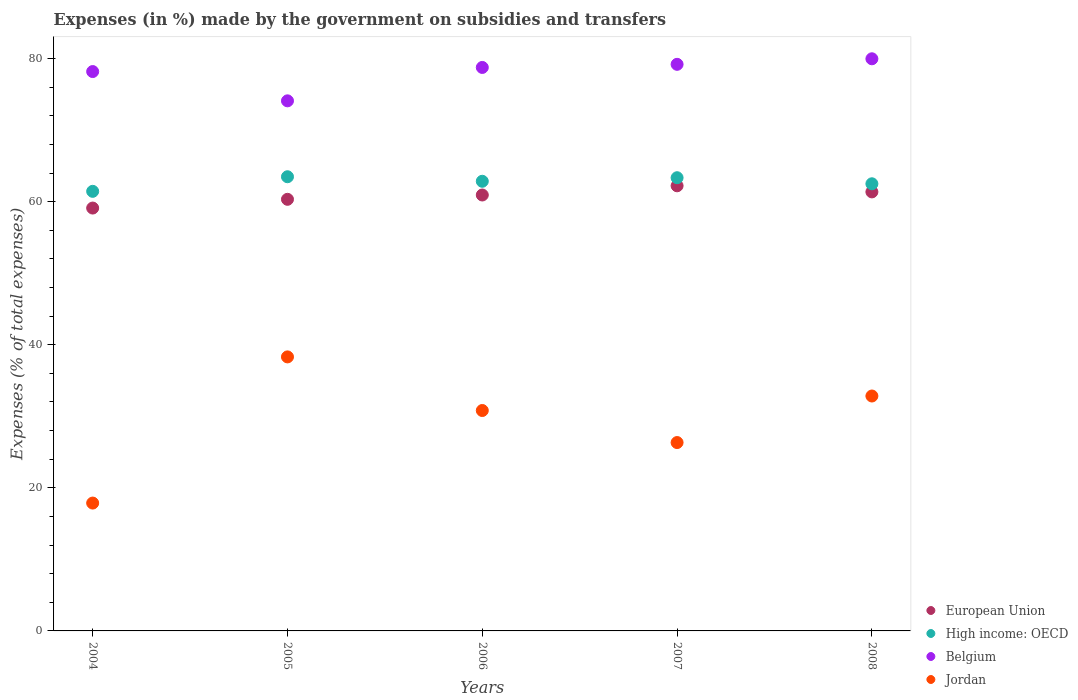Is the number of dotlines equal to the number of legend labels?
Ensure brevity in your answer.  Yes. What is the percentage of expenses made by the government on subsidies and transfers in Jordan in 2005?
Offer a very short reply. 38.3. Across all years, what is the maximum percentage of expenses made by the government on subsidies and transfers in High income: OECD?
Offer a very short reply. 63.48. Across all years, what is the minimum percentage of expenses made by the government on subsidies and transfers in European Union?
Make the answer very short. 59.11. In which year was the percentage of expenses made by the government on subsidies and transfers in Jordan maximum?
Give a very brief answer. 2005. In which year was the percentage of expenses made by the government on subsidies and transfers in Jordan minimum?
Offer a terse response. 2004. What is the total percentage of expenses made by the government on subsidies and transfers in Jordan in the graph?
Provide a short and direct response. 146.15. What is the difference between the percentage of expenses made by the government on subsidies and transfers in High income: OECD in 2004 and that in 2005?
Your answer should be very brief. -2.04. What is the difference between the percentage of expenses made by the government on subsidies and transfers in European Union in 2004 and the percentage of expenses made by the government on subsidies and transfers in Jordan in 2005?
Provide a succinct answer. 20.8. What is the average percentage of expenses made by the government on subsidies and transfers in Jordan per year?
Make the answer very short. 29.23. In the year 2006, what is the difference between the percentage of expenses made by the government on subsidies and transfers in Belgium and percentage of expenses made by the government on subsidies and transfers in European Union?
Your response must be concise. 17.83. What is the ratio of the percentage of expenses made by the government on subsidies and transfers in European Union in 2007 to that in 2008?
Offer a very short reply. 1.01. Is the difference between the percentage of expenses made by the government on subsidies and transfers in Belgium in 2004 and 2007 greater than the difference between the percentage of expenses made by the government on subsidies and transfers in European Union in 2004 and 2007?
Your answer should be very brief. Yes. What is the difference between the highest and the second highest percentage of expenses made by the government on subsidies and transfers in Jordan?
Your answer should be very brief. 5.47. What is the difference between the highest and the lowest percentage of expenses made by the government on subsidies and transfers in Belgium?
Ensure brevity in your answer.  5.88. In how many years, is the percentage of expenses made by the government on subsidies and transfers in European Union greater than the average percentage of expenses made by the government on subsidies and transfers in European Union taken over all years?
Your answer should be compact. 3. Is the sum of the percentage of expenses made by the government on subsidies and transfers in European Union in 2007 and 2008 greater than the maximum percentage of expenses made by the government on subsidies and transfers in High income: OECD across all years?
Make the answer very short. Yes. Is it the case that in every year, the sum of the percentage of expenses made by the government on subsidies and transfers in Belgium and percentage of expenses made by the government on subsidies and transfers in European Union  is greater than the percentage of expenses made by the government on subsidies and transfers in High income: OECD?
Give a very brief answer. Yes. Is the percentage of expenses made by the government on subsidies and transfers in European Union strictly greater than the percentage of expenses made by the government on subsidies and transfers in Jordan over the years?
Your answer should be very brief. Yes. What is the difference between two consecutive major ticks on the Y-axis?
Provide a short and direct response. 20. Are the values on the major ticks of Y-axis written in scientific E-notation?
Your answer should be compact. No. How are the legend labels stacked?
Offer a very short reply. Vertical. What is the title of the graph?
Give a very brief answer. Expenses (in %) made by the government on subsidies and transfers. Does "Japan" appear as one of the legend labels in the graph?
Ensure brevity in your answer.  No. What is the label or title of the Y-axis?
Offer a very short reply. Expenses (% of total expenses). What is the Expenses (% of total expenses) in European Union in 2004?
Make the answer very short. 59.11. What is the Expenses (% of total expenses) of High income: OECD in 2004?
Your response must be concise. 61.44. What is the Expenses (% of total expenses) in Belgium in 2004?
Keep it short and to the point. 78.19. What is the Expenses (% of total expenses) in Jordan in 2004?
Provide a succinct answer. 17.87. What is the Expenses (% of total expenses) in European Union in 2005?
Your response must be concise. 60.33. What is the Expenses (% of total expenses) of High income: OECD in 2005?
Give a very brief answer. 63.48. What is the Expenses (% of total expenses) of Belgium in 2005?
Provide a short and direct response. 74.09. What is the Expenses (% of total expenses) in Jordan in 2005?
Ensure brevity in your answer.  38.3. What is the Expenses (% of total expenses) in European Union in 2006?
Make the answer very short. 60.93. What is the Expenses (% of total expenses) in High income: OECD in 2006?
Provide a short and direct response. 62.85. What is the Expenses (% of total expenses) of Belgium in 2006?
Your answer should be very brief. 78.76. What is the Expenses (% of total expenses) of Jordan in 2006?
Your answer should be compact. 30.81. What is the Expenses (% of total expenses) in European Union in 2007?
Make the answer very short. 62.22. What is the Expenses (% of total expenses) of High income: OECD in 2007?
Your answer should be compact. 63.35. What is the Expenses (% of total expenses) of Belgium in 2007?
Make the answer very short. 79.2. What is the Expenses (% of total expenses) of Jordan in 2007?
Ensure brevity in your answer.  26.33. What is the Expenses (% of total expenses) of European Union in 2008?
Provide a succinct answer. 61.36. What is the Expenses (% of total expenses) of High income: OECD in 2008?
Make the answer very short. 62.5. What is the Expenses (% of total expenses) of Belgium in 2008?
Offer a terse response. 79.97. What is the Expenses (% of total expenses) of Jordan in 2008?
Make the answer very short. 32.84. Across all years, what is the maximum Expenses (% of total expenses) of European Union?
Give a very brief answer. 62.22. Across all years, what is the maximum Expenses (% of total expenses) in High income: OECD?
Make the answer very short. 63.48. Across all years, what is the maximum Expenses (% of total expenses) in Belgium?
Your answer should be very brief. 79.97. Across all years, what is the maximum Expenses (% of total expenses) in Jordan?
Your answer should be compact. 38.3. Across all years, what is the minimum Expenses (% of total expenses) of European Union?
Your answer should be compact. 59.11. Across all years, what is the minimum Expenses (% of total expenses) of High income: OECD?
Offer a very short reply. 61.44. Across all years, what is the minimum Expenses (% of total expenses) in Belgium?
Keep it short and to the point. 74.09. Across all years, what is the minimum Expenses (% of total expenses) of Jordan?
Give a very brief answer. 17.87. What is the total Expenses (% of total expenses) in European Union in the graph?
Give a very brief answer. 303.95. What is the total Expenses (% of total expenses) in High income: OECD in the graph?
Your answer should be very brief. 313.62. What is the total Expenses (% of total expenses) of Belgium in the graph?
Provide a short and direct response. 390.2. What is the total Expenses (% of total expenses) of Jordan in the graph?
Provide a succinct answer. 146.15. What is the difference between the Expenses (% of total expenses) in European Union in 2004 and that in 2005?
Your response must be concise. -1.22. What is the difference between the Expenses (% of total expenses) of High income: OECD in 2004 and that in 2005?
Make the answer very short. -2.04. What is the difference between the Expenses (% of total expenses) in Belgium in 2004 and that in 2005?
Offer a very short reply. 4.09. What is the difference between the Expenses (% of total expenses) in Jordan in 2004 and that in 2005?
Keep it short and to the point. -20.43. What is the difference between the Expenses (% of total expenses) in European Union in 2004 and that in 2006?
Ensure brevity in your answer.  -1.83. What is the difference between the Expenses (% of total expenses) in High income: OECD in 2004 and that in 2006?
Your answer should be compact. -1.41. What is the difference between the Expenses (% of total expenses) in Belgium in 2004 and that in 2006?
Provide a short and direct response. -0.57. What is the difference between the Expenses (% of total expenses) in Jordan in 2004 and that in 2006?
Offer a terse response. -12.94. What is the difference between the Expenses (% of total expenses) of European Union in 2004 and that in 2007?
Your response must be concise. -3.11. What is the difference between the Expenses (% of total expenses) in High income: OECD in 2004 and that in 2007?
Keep it short and to the point. -1.9. What is the difference between the Expenses (% of total expenses) of Belgium in 2004 and that in 2007?
Provide a succinct answer. -1.01. What is the difference between the Expenses (% of total expenses) in Jordan in 2004 and that in 2007?
Your answer should be compact. -8.46. What is the difference between the Expenses (% of total expenses) of European Union in 2004 and that in 2008?
Provide a succinct answer. -2.26. What is the difference between the Expenses (% of total expenses) in High income: OECD in 2004 and that in 2008?
Offer a terse response. -1.06. What is the difference between the Expenses (% of total expenses) of Belgium in 2004 and that in 2008?
Give a very brief answer. -1.79. What is the difference between the Expenses (% of total expenses) in Jordan in 2004 and that in 2008?
Make the answer very short. -14.96. What is the difference between the Expenses (% of total expenses) in European Union in 2005 and that in 2006?
Your response must be concise. -0.6. What is the difference between the Expenses (% of total expenses) of High income: OECD in 2005 and that in 2006?
Keep it short and to the point. 0.63. What is the difference between the Expenses (% of total expenses) in Belgium in 2005 and that in 2006?
Your response must be concise. -4.67. What is the difference between the Expenses (% of total expenses) in Jordan in 2005 and that in 2006?
Offer a very short reply. 7.49. What is the difference between the Expenses (% of total expenses) in European Union in 2005 and that in 2007?
Make the answer very short. -1.89. What is the difference between the Expenses (% of total expenses) of High income: OECD in 2005 and that in 2007?
Keep it short and to the point. 0.14. What is the difference between the Expenses (% of total expenses) in Belgium in 2005 and that in 2007?
Offer a very short reply. -5.1. What is the difference between the Expenses (% of total expenses) of Jordan in 2005 and that in 2007?
Provide a succinct answer. 11.97. What is the difference between the Expenses (% of total expenses) of European Union in 2005 and that in 2008?
Your answer should be compact. -1.04. What is the difference between the Expenses (% of total expenses) in High income: OECD in 2005 and that in 2008?
Offer a very short reply. 0.98. What is the difference between the Expenses (% of total expenses) of Belgium in 2005 and that in 2008?
Give a very brief answer. -5.88. What is the difference between the Expenses (% of total expenses) in Jordan in 2005 and that in 2008?
Provide a succinct answer. 5.47. What is the difference between the Expenses (% of total expenses) of European Union in 2006 and that in 2007?
Ensure brevity in your answer.  -1.29. What is the difference between the Expenses (% of total expenses) of High income: OECD in 2006 and that in 2007?
Make the answer very short. -0.5. What is the difference between the Expenses (% of total expenses) of Belgium in 2006 and that in 2007?
Give a very brief answer. -0.44. What is the difference between the Expenses (% of total expenses) in Jordan in 2006 and that in 2007?
Offer a very short reply. 4.48. What is the difference between the Expenses (% of total expenses) of European Union in 2006 and that in 2008?
Make the answer very short. -0.43. What is the difference between the Expenses (% of total expenses) of High income: OECD in 2006 and that in 2008?
Keep it short and to the point. 0.35. What is the difference between the Expenses (% of total expenses) in Belgium in 2006 and that in 2008?
Ensure brevity in your answer.  -1.21. What is the difference between the Expenses (% of total expenses) in Jordan in 2006 and that in 2008?
Your answer should be very brief. -2.03. What is the difference between the Expenses (% of total expenses) of European Union in 2007 and that in 2008?
Give a very brief answer. 0.85. What is the difference between the Expenses (% of total expenses) in High income: OECD in 2007 and that in 2008?
Your answer should be very brief. 0.85. What is the difference between the Expenses (% of total expenses) of Belgium in 2007 and that in 2008?
Make the answer very short. -0.77. What is the difference between the Expenses (% of total expenses) in Jordan in 2007 and that in 2008?
Keep it short and to the point. -6.51. What is the difference between the Expenses (% of total expenses) in European Union in 2004 and the Expenses (% of total expenses) in High income: OECD in 2005?
Make the answer very short. -4.38. What is the difference between the Expenses (% of total expenses) in European Union in 2004 and the Expenses (% of total expenses) in Belgium in 2005?
Your response must be concise. -14.99. What is the difference between the Expenses (% of total expenses) in European Union in 2004 and the Expenses (% of total expenses) in Jordan in 2005?
Provide a short and direct response. 20.8. What is the difference between the Expenses (% of total expenses) in High income: OECD in 2004 and the Expenses (% of total expenses) in Belgium in 2005?
Your response must be concise. -12.65. What is the difference between the Expenses (% of total expenses) of High income: OECD in 2004 and the Expenses (% of total expenses) of Jordan in 2005?
Keep it short and to the point. 23.14. What is the difference between the Expenses (% of total expenses) of Belgium in 2004 and the Expenses (% of total expenses) of Jordan in 2005?
Your answer should be compact. 39.88. What is the difference between the Expenses (% of total expenses) of European Union in 2004 and the Expenses (% of total expenses) of High income: OECD in 2006?
Make the answer very short. -3.74. What is the difference between the Expenses (% of total expenses) in European Union in 2004 and the Expenses (% of total expenses) in Belgium in 2006?
Give a very brief answer. -19.65. What is the difference between the Expenses (% of total expenses) of European Union in 2004 and the Expenses (% of total expenses) of Jordan in 2006?
Your answer should be compact. 28.3. What is the difference between the Expenses (% of total expenses) of High income: OECD in 2004 and the Expenses (% of total expenses) of Belgium in 2006?
Provide a short and direct response. -17.32. What is the difference between the Expenses (% of total expenses) of High income: OECD in 2004 and the Expenses (% of total expenses) of Jordan in 2006?
Offer a terse response. 30.64. What is the difference between the Expenses (% of total expenses) in Belgium in 2004 and the Expenses (% of total expenses) in Jordan in 2006?
Your response must be concise. 47.38. What is the difference between the Expenses (% of total expenses) of European Union in 2004 and the Expenses (% of total expenses) of High income: OECD in 2007?
Give a very brief answer. -4.24. What is the difference between the Expenses (% of total expenses) of European Union in 2004 and the Expenses (% of total expenses) of Belgium in 2007?
Your response must be concise. -20.09. What is the difference between the Expenses (% of total expenses) of European Union in 2004 and the Expenses (% of total expenses) of Jordan in 2007?
Keep it short and to the point. 32.78. What is the difference between the Expenses (% of total expenses) of High income: OECD in 2004 and the Expenses (% of total expenses) of Belgium in 2007?
Your response must be concise. -17.75. What is the difference between the Expenses (% of total expenses) of High income: OECD in 2004 and the Expenses (% of total expenses) of Jordan in 2007?
Offer a terse response. 35.11. What is the difference between the Expenses (% of total expenses) in Belgium in 2004 and the Expenses (% of total expenses) in Jordan in 2007?
Your answer should be compact. 51.86. What is the difference between the Expenses (% of total expenses) of European Union in 2004 and the Expenses (% of total expenses) of High income: OECD in 2008?
Your response must be concise. -3.39. What is the difference between the Expenses (% of total expenses) of European Union in 2004 and the Expenses (% of total expenses) of Belgium in 2008?
Make the answer very short. -20.86. What is the difference between the Expenses (% of total expenses) of European Union in 2004 and the Expenses (% of total expenses) of Jordan in 2008?
Your answer should be very brief. 26.27. What is the difference between the Expenses (% of total expenses) of High income: OECD in 2004 and the Expenses (% of total expenses) of Belgium in 2008?
Offer a very short reply. -18.53. What is the difference between the Expenses (% of total expenses) of High income: OECD in 2004 and the Expenses (% of total expenses) of Jordan in 2008?
Your answer should be very brief. 28.61. What is the difference between the Expenses (% of total expenses) in Belgium in 2004 and the Expenses (% of total expenses) in Jordan in 2008?
Offer a terse response. 45.35. What is the difference between the Expenses (% of total expenses) of European Union in 2005 and the Expenses (% of total expenses) of High income: OECD in 2006?
Your answer should be very brief. -2.52. What is the difference between the Expenses (% of total expenses) in European Union in 2005 and the Expenses (% of total expenses) in Belgium in 2006?
Offer a very short reply. -18.43. What is the difference between the Expenses (% of total expenses) in European Union in 2005 and the Expenses (% of total expenses) in Jordan in 2006?
Your response must be concise. 29.52. What is the difference between the Expenses (% of total expenses) of High income: OECD in 2005 and the Expenses (% of total expenses) of Belgium in 2006?
Provide a short and direct response. -15.28. What is the difference between the Expenses (% of total expenses) of High income: OECD in 2005 and the Expenses (% of total expenses) of Jordan in 2006?
Your answer should be very brief. 32.67. What is the difference between the Expenses (% of total expenses) in Belgium in 2005 and the Expenses (% of total expenses) in Jordan in 2006?
Your response must be concise. 43.28. What is the difference between the Expenses (% of total expenses) in European Union in 2005 and the Expenses (% of total expenses) in High income: OECD in 2007?
Your response must be concise. -3.02. What is the difference between the Expenses (% of total expenses) of European Union in 2005 and the Expenses (% of total expenses) of Belgium in 2007?
Offer a very short reply. -18.87. What is the difference between the Expenses (% of total expenses) of European Union in 2005 and the Expenses (% of total expenses) of Jordan in 2007?
Your answer should be very brief. 34. What is the difference between the Expenses (% of total expenses) of High income: OECD in 2005 and the Expenses (% of total expenses) of Belgium in 2007?
Make the answer very short. -15.71. What is the difference between the Expenses (% of total expenses) in High income: OECD in 2005 and the Expenses (% of total expenses) in Jordan in 2007?
Offer a terse response. 37.15. What is the difference between the Expenses (% of total expenses) of Belgium in 2005 and the Expenses (% of total expenses) of Jordan in 2007?
Your answer should be very brief. 47.76. What is the difference between the Expenses (% of total expenses) of European Union in 2005 and the Expenses (% of total expenses) of High income: OECD in 2008?
Provide a succinct answer. -2.17. What is the difference between the Expenses (% of total expenses) of European Union in 2005 and the Expenses (% of total expenses) of Belgium in 2008?
Ensure brevity in your answer.  -19.64. What is the difference between the Expenses (% of total expenses) in European Union in 2005 and the Expenses (% of total expenses) in Jordan in 2008?
Give a very brief answer. 27.49. What is the difference between the Expenses (% of total expenses) in High income: OECD in 2005 and the Expenses (% of total expenses) in Belgium in 2008?
Offer a very short reply. -16.49. What is the difference between the Expenses (% of total expenses) in High income: OECD in 2005 and the Expenses (% of total expenses) in Jordan in 2008?
Your response must be concise. 30.65. What is the difference between the Expenses (% of total expenses) in Belgium in 2005 and the Expenses (% of total expenses) in Jordan in 2008?
Provide a succinct answer. 41.26. What is the difference between the Expenses (% of total expenses) of European Union in 2006 and the Expenses (% of total expenses) of High income: OECD in 2007?
Your answer should be very brief. -2.41. What is the difference between the Expenses (% of total expenses) in European Union in 2006 and the Expenses (% of total expenses) in Belgium in 2007?
Make the answer very short. -18.26. What is the difference between the Expenses (% of total expenses) of European Union in 2006 and the Expenses (% of total expenses) of Jordan in 2007?
Your response must be concise. 34.6. What is the difference between the Expenses (% of total expenses) in High income: OECD in 2006 and the Expenses (% of total expenses) in Belgium in 2007?
Keep it short and to the point. -16.35. What is the difference between the Expenses (% of total expenses) in High income: OECD in 2006 and the Expenses (% of total expenses) in Jordan in 2007?
Ensure brevity in your answer.  36.52. What is the difference between the Expenses (% of total expenses) of Belgium in 2006 and the Expenses (% of total expenses) of Jordan in 2007?
Provide a succinct answer. 52.43. What is the difference between the Expenses (% of total expenses) in European Union in 2006 and the Expenses (% of total expenses) in High income: OECD in 2008?
Offer a very short reply. -1.57. What is the difference between the Expenses (% of total expenses) of European Union in 2006 and the Expenses (% of total expenses) of Belgium in 2008?
Ensure brevity in your answer.  -19.04. What is the difference between the Expenses (% of total expenses) in European Union in 2006 and the Expenses (% of total expenses) in Jordan in 2008?
Give a very brief answer. 28.1. What is the difference between the Expenses (% of total expenses) in High income: OECD in 2006 and the Expenses (% of total expenses) in Belgium in 2008?
Make the answer very short. -17.12. What is the difference between the Expenses (% of total expenses) of High income: OECD in 2006 and the Expenses (% of total expenses) of Jordan in 2008?
Your answer should be compact. 30.01. What is the difference between the Expenses (% of total expenses) in Belgium in 2006 and the Expenses (% of total expenses) in Jordan in 2008?
Your response must be concise. 45.92. What is the difference between the Expenses (% of total expenses) in European Union in 2007 and the Expenses (% of total expenses) in High income: OECD in 2008?
Provide a succinct answer. -0.28. What is the difference between the Expenses (% of total expenses) in European Union in 2007 and the Expenses (% of total expenses) in Belgium in 2008?
Give a very brief answer. -17.75. What is the difference between the Expenses (% of total expenses) of European Union in 2007 and the Expenses (% of total expenses) of Jordan in 2008?
Your answer should be compact. 29.38. What is the difference between the Expenses (% of total expenses) in High income: OECD in 2007 and the Expenses (% of total expenses) in Belgium in 2008?
Offer a very short reply. -16.62. What is the difference between the Expenses (% of total expenses) of High income: OECD in 2007 and the Expenses (% of total expenses) of Jordan in 2008?
Give a very brief answer. 30.51. What is the difference between the Expenses (% of total expenses) of Belgium in 2007 and the Expenses (% of total expenses) of Jordan in 2008?
Make the answer very short. 46.36. What is the average Expenses (% of total expenses) of European Union per year?
Offer a very short reply. 60.79. What is the average Expenses (% of total expenses) in High income: OECD per year?
Make the answer very short. 62.72. What is the average Expenses (% of total expenses) of Belgium per year?
Your response must be concise. 78.04. What is the average Expenses (% of total expenses) in Jordan per year?
Provide a short and direct response. 29.23. In the year 2004, what is the difference between the Expenses (% of total expenses) of European Union and Expenses (% of total expenses) of High income: OECD?
Offer a very short reply. -2.34. In the year 2004, what is the difference between the Expenses (% of total expenses) of European Union and Expenses (% of total expenses) of Belgium?
Offer a terse response. -19.08. In the year 2004, what is the difference between the Expenses (% of total expenses) in European Union and Expenses (% of total expenses) in Jordan?
Your answer should be very brief. 41.23. In the year 2004, what is the difference between the Expenses (% of total expenses) in High income: OECD and Expenses (% of total expenses) in Belgium?
Ensure brevity in your answer.  -16.74. In the year 2004, what is the difference between the Expenses (% of total expenses) in High income: OECD and Expenses (% of total expenses) in Jordan?
Your response must be concise. 43.57. In the year 2004, what is the difference between the Expenses (% of total expenses) in Belgium and Expenses (% of total expenses) in Jordan?
Provide a short and direct response. 60.31. In the year 2005, what is the difference between the Expenses (% of total expenses) in European Union and Expenses (% of total expenses) in High income: OECD?
Offer a very short reply. -3.15. In the year 2005, what is the difference between the Expenses (% of total expenses) in European Union and Expenses (% of total expenses) in Belgium?
Offer a terse response. -13.76. In the year 2005, what is the difference between the Expenses (% of total expenses) of European Union and Expenses (% of total expenses) of Jordan?
Offer a very short reply. 22.03. In the year 2005, what is the difference between the Expenses (% of total expenses) in High income: OECD and Expenses (% of total expenses) in Belgium?
Provide a short and direct response. -10.61. In the year 2005, what is the difference between the Expenses (% of total expenses) in High income: OECD and Expenses (% of total expenses) in Jordan?
Keep it short and to the point. 25.18. In the year 2005, what is the difference between the Expenses (% of total expenses) of Belgium and Expenses (% of total expenses) of Jordan?
Give a very brief answer. 35.79. In the year 2006, what is the difference between the Expenses (% of total expenses) of European Union and Expenses (% of total expenses) of High income: OECD?
Offer a very short reply. -1.92. In the year 2006, what is the difference between the Expenses (% of total expenses) in European Union and Expenses (% of total expenses) in Belgium?
Offer a very short reply. -17.83. In the year 2006, what is the difference between the Expenses (% of total expenses) in European Union and Expenses (% of total expenses) in Jordan?
Offer a terse response. 30.12. In the year 2006, what is the difference between the Expenses (% of total expenses) of High income: OECD and Expenses (% of total expenses) of Belgium?
Give a very brief answer. -15.91. In the year 2006, what is the difference between the Expenses (% of total expenses) in High income: OECD and Expenses (% of total expenses) in Jordan?
Offer a very short reply. 32.04. In the year 2006, what is the difference between the Expenses (% of total expenses) in Belgium and Expenses (% of total expenses) in Jordan?
Make the answer very short. 47.95. In the year 2007, what is the difference between the Expenses (% of total expenses) of European Union and Expenses (% of total expenses) of High income: OECD?
Provide a succinct answer. -1.13. In the year 2007, what is the difference between the Expenses (% of total expenses) of European Union and Expenses (% of total expenses) of Belgium?
Make the answer very short. -16.98. In the year 2007, what is the difference between the Expenses (% of total expenses) in European Union and Expenses (% of total expenses) in Jordan?
Offer a very short reply. 35.89. In the year 2007, what is the difference between the Expenses (% of total expenses) in High income: OECD and Expenses (% of total expenses) in Belgium?
Your answer should be very brief. -15.85. In the year 2007, what is the difference between the Expenses (% of total expenses) of High income: OECD and Expenses (% of total expenses) of Jordan?
Your answer should be compact. 37.02. In the year 2007, what is the difference between the Expenses (% of total expenses) in Belgium and Expenses (% of total expenses) in Jordan?
Offer a very short reply. 52.87. In the year 2008, what is the difference between the Expenses (% of total expenses) in European Union and Expenses (% of total expenses) in High income: OECD?
Give a very brief answer. -1.14. In the year 2008, what is the difference between the Expenses (% of total expenses) of European Union and Expenses (% of total expenses) of Belgium?
Your response must be concise. -18.61. In the year 2008, what is the difference between the Expenses (% of total expenses) in European Union and Expenses (% of total expenses) in Jordan?
Make the answer very short. 28.53. In the year 2008, what is the difference between the Expenses (% of total expenses) in High income: OECD and Expenses (% of total expenses) in Belgium?
Make the answer very short. -17.47. In the year 2008, what is the difference between the Expenses (% of total expenses) of High income: OECD and Expenses (% of total expenses) of Jordan?
Make the answer very short. 29.66. In the year 2008, what is the difference between the Expenses (% of total expenses) of Belgium and Expenses (% of total expenses) of Jordan?
Make the answer very short. 47.14. What is the ratio of the Expenses (% of total expenses) in European Union in 2004 to that in 2005?
Your response must be concise. 0.98. What is the ratio of the Expenses (% of total expenses) in High income: OECD in 2004 to that in 2005?
Offer a very short reply. 0.97. What is the ratio of the Expenses (% of total expenses) in Belgium in 2004 to that in 2005?
Give a very brief answer. 1.06. What is the ratio of the Expenses (% of total expenses) of Jordan in 2004 to that in 2005?
Offer a very short reply. 0.47. What is the ratio of the Expenses (% of total expenses) of European Union in 2004 to that in 2006?
Give a very brief answer. 0.97. What is the ratio of the Expenses (% of total expenses) in High income: OECD in 2004 to that in 2006?
Make the answer very short. 0.98. What is the ratio of the Expenses (% of total expenses) of Jordan in 2004 to that in 2006?
Keep it short and to the point. 0.58. What is the ratio of the Expenses (% of total expenses) of European Union in 2004 to that in 2007?
Your response must be concise. 0.95. What is the ratio of the Expenses (% of total expenses) of High income: OECD in 2004 to that in 2007?
Make the answer very short. 0.97. What is the ratio of the Expenses (% of total expenses) in Belgium in 2004 to that in 2007?
Provide a succinct answer. 0.99. What is the ratio of the Expenses (% of total expenses) of Jordan in 2004 to that in 2007?
Give a very brief answer. 0.68. What is the ratio of the Expenses (% of total expenses) of European Union in 2004 to that in 2008?
Offer a terse response. 0.96. What is the ratio of the Expenses (% of total expenses) of High income: OECD in 2004 to that in 2008?
Provide a succinct answer. 0.98. What is the ratio of the Expenses (% of total expenses) in Belgium in 2004 to that in 2008?
Provide a succinct answer. 0.98. What is the ratio of the Expenses (% of total expenses) in Jordan in 2004 to that in 2008?
Provide a short and direct response. 0.54. What is the ratio of the Expenses (% of total expenses) in European Union in 2005 to that in 2006?
Your response must be concise. 0.99. What is the ratio of the Expenses (% of total expenses) of Belgium in 2005 to that in 2006?
Offer a terse response. 0.94. What is the ratio of the Expenses (% of total expenses) in Jordan in 2005 to that in 2006?
Offer a very short reply. 1.24. What is the ratio of the Expenses (% of total expenses) in European Union in 2005 to that in 2007?
Ensure brevity in your answer.  0.97. What is the ratio of the Expenses (% of total expenses) in Belgium in 2005 to that in 2007?
Ensure brevity in your answer.  0.94. What is the ratio of the Expenses (% of total expenses) of Jordan in 2005 to that in 2007?
Your answer should be very brief. 1.45. What is the ratio of the Expenses (% of total expenses) in European Union in 2005 to that in 2008?
Give a very brief answer. 0.98. What is the ratio of the Expenses (% of total expenses) in High income: OECD in 2005 to that in 2008?
Offer a terse response. 1.02. What is the ratio of the Expenses (% of total expenses) of Belgium in 2005 to that in 2008?
Your answer should be compact. 0.93. What is the ratio of the Expenses (% of total expenses) of Jordan in 2005 to that in 2008?
Offer a very short reply. 1.17. What is the ratio of the Expenses (% of total expenses) in European Union in 2006 to that in 2007?
Offer a terse response. 0.98. What is the ratio of the Expenses (% of total expenses) in High income: OECD in 2006 to that in 2007?
Give a very brief answer. 0.99. What is the ratio of the Expenses (% of total expenses) in Jordan in 2006 to that in 2007?
Give a very brief answer. 1.17. What is the ratio of the Expenses (% of total expenses) in High income: OECD in 2006 to that in 2008?
Make the answer very short. 1.01. What is the ratio of the Expenses (% of total expenses) of Belgium in 2006 to that in 2008?
Your answer should be very brief. 0.98. What is the ratio of the Expenses (% of total expenses) of Jordan in 2006 to that in 2008?
Your response must be concise. 0.94. What is the ratio of the Expenses (% of total expenses) of European Union in 2007 to that in 2008?
Offer a terse response. 1.01. What is the ratio of the Expenses (% of total expenses) of High income: OECD in 2007 to that in 2008?
Give a very brief answer. 1.01. What is the ratio of the Expenses (% of total expenses) of Belgium in 2007 to that in 2008?
Provide a succinct answer. 0.99. What is the ratio of the Expenses (% of total expenses) in Jordan in 2007 to that in 2008?
Provide a short and direct response. 0.8. What is the difference between the highest and the second highest Expenses (% of total expenses) in European Union?
Provide a succinct answer. 0.85. What is the difference between the highest and the second highest Expenses (% of total expenses) in High income: OECD?
Your response must be concise. 0.14. What is the difference between the highest and the second highest Expenses (% of total expenses) of Belgium?
Give a very brief answer. 0.77. What is the difference between the highest and the second highest Expenses (% of total expenses) of Jordan?
Ensure brevity in your answer.  5.47. What is the difference between the highest and the lowest Expenses (% of total expenses) of European Union?
Provide a succinct answer. 3.11. What is the difference between the highest and the lowest Expenses (% of total expenses) of High income: OECD?
Ensure brevity in your answer.  2.04. What is the difference between the highest and the lowest Expenses (% of total expenses) of Belgium?
Make the answer very short. 5.88. What is the difference between the highest and the lowest Expenses (% of total expenses) of Jordan?
Your answer should be compact. 20.43. 